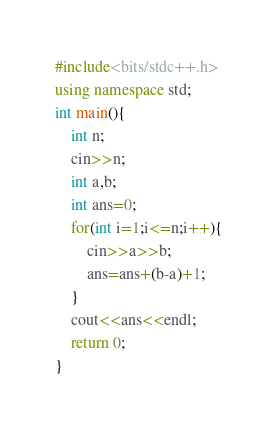<code> <loc_0><loc_0><loc_500><loc_500><_C++_>#include<bits/stdc++.h>
using namespace std;
int main(){
	int n;
	cin>>n;
	int a,b;
	int ans=0;
	for(int i=1;i<=n;i++){
		cin>>a>>b;
		ans=ans+(b-a)+1; 
	} 
	cout<<ans<<endl;
	return 0;
}</code> 